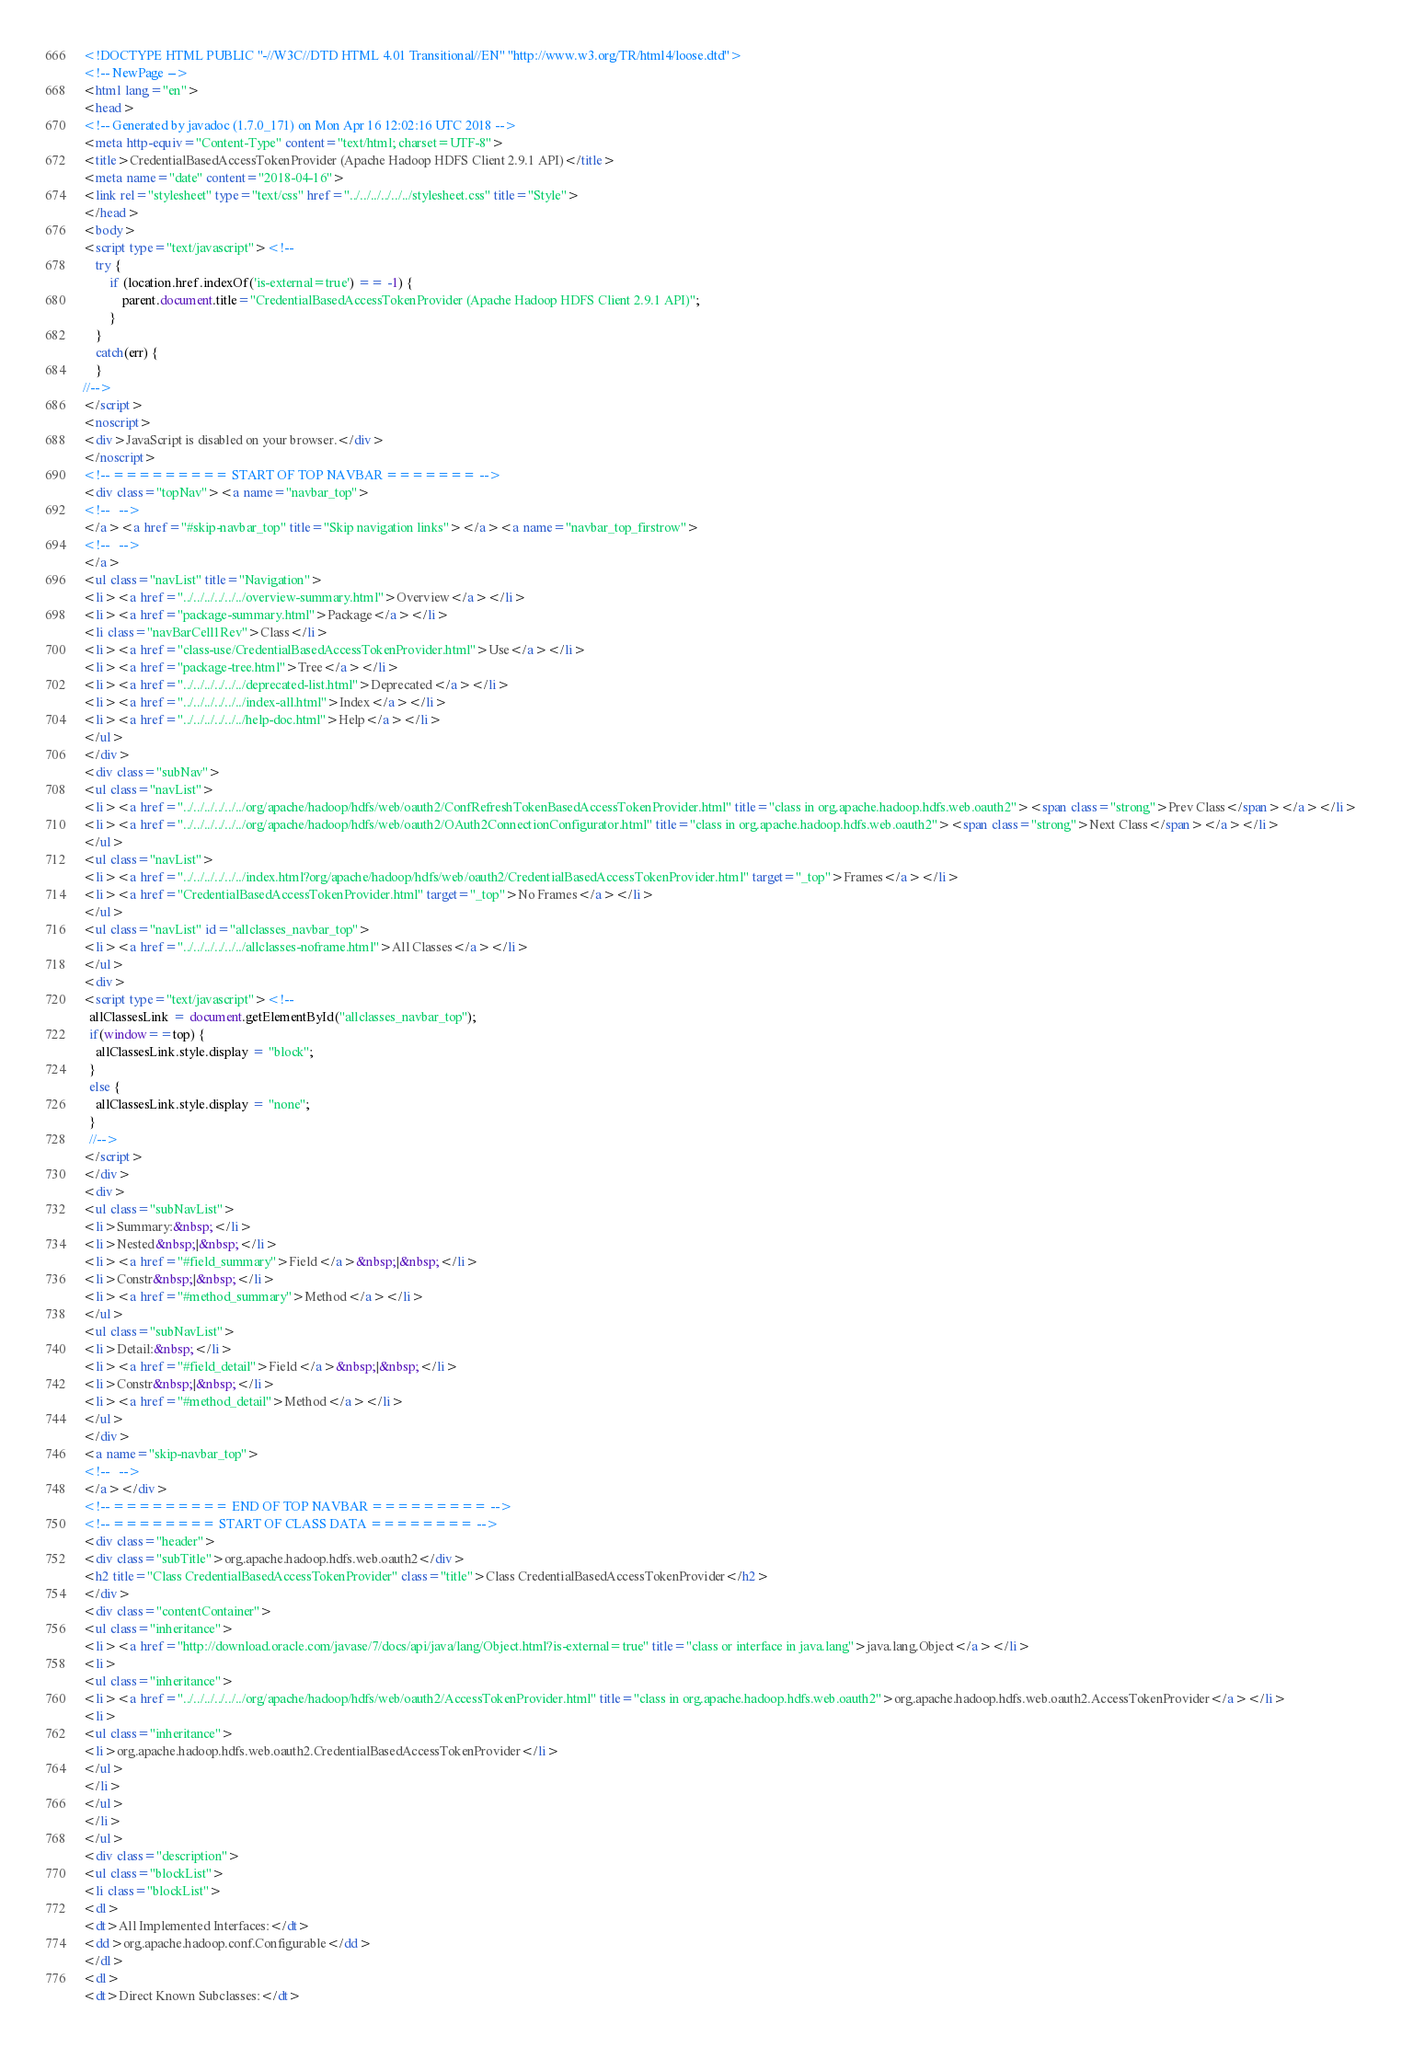Convert code to text. <code><loc_0><loc_0><loc_500><loc_500><_HTML_><!DOCTYPE HTML PUBLIC "-//W3C//DTD HTML 4.01 Transitional//EN" "http://www.w3.org/TR/html4/loose.dtd">
<!-- NewPage -->
<html lang="en">
<head>
<!-- Generated by javadoc (1.7.0_171) on Mon Apr 16 12:02:16 UTC 2018 -->
<meta http-equiv="Content-Type" content="text/html; charset=UTF-8">
<title>CredentialBasedAccessTokenProvider (Apache Hadoop HDFS Client 2.9.1 API)</title>
<meta name="date" content="2018-04-16">
<link rel="stylesheet" type="text/css" href="../../../../../../stylesheet.css" title="Style">
</head>
<body>
<script type="text/javascript"><!--
    try {
        if (location.href.indexOf('is-external=true') == -1) {
            parent.document.title="CredentialBasedAccessTokenProvider (Apache Hadoop HDFS Client 2.9.1 API)";
        }
    }
    catch(err) {
    }
//-->
</script>
<noscript>
<div>JavaScript is disabled on your browser.</div>
</noscript>
<!-- ========= START OF TOP NAVBAR ======= -->
<div class="topNav"><a name="navbar_top">
<!--   -->
</a><a href="#skip-navbar_top" title="Skip navigation links"></a><a name="navbar_top_firstrow">
<!--   -->
</a>
<ul class="navList" title="Navigation">
<li><a href="../../../../../../overview-summary.html">Overview</a></li>
<li><a href="package-summary.html">Package</a></li>
<li class="navBarCell1Rev">Class</li>
<li><a href="class-use/CredentialBasedAccessTokenProvider.html">Use</a></li>
<li><a href="package-tree.html">Tree</a></li>
<li><a href="../../../../../../deprecated-list.html">Deprecated</a></li>
<li><a href="../../../../../../index-all.html">Index</a></li>
<li><a href="../../../../../../help-doc.html">Help</a></li>
</ul>
</div>
<div class="subNav">
<ul class="navList">
<li><a href="../../../../../../org/apache/hadoop/hdfs/web/oauth2/ConfRefreshTokenBasedAccessTokenProvider.html" title="class in org.apache.hadoop.hdfs.web.oauth2"><span class="strong">Prev Class</span></a></li>
<li><a href="../../../../../../org/apache/hadoop/hdfs/web/oauth2/OAuth2ConnectionConfigurator.html" title="class in org.apache.hadoop.hdfs.web.oauth2"><span class="strong">Next Class</span></a></li>
</ul>
<ul class="navList">
<li><a href="../../../../../../index.html?org/apache/hadoop/hdfs/web/oauth2/CredentialBasedAccessTokenProvider.html" target="_top">Frames</a></li>
<li><a href="CredentialBasedAccessTokenProvider.html" target="_top">No Frames</a></li>
</ul>
<ul class="navList" id="allclasses_navbar_top">
<li><a href="../../../../../../allclasses-noframe.html">All Classes</a></li>
</ul>
<div>
<script type="text/javascript"><!--
  allClassesLink = document.getElementById("allclasses_navbar_top");
  if(window==top) {
    allClassesLink.style.display = "block";
  }
  else {
    allClassesLink.style.display = "none";
  }
  //-->
</script>
</div>
<div>
<ul class="subNavList">
<li>Summary:&nbsp;</li>
<li>Nested&nbsp;|&nbsp;</li>
<li><a href="#field_summary">Field</a>&nbsp;|&nbsp;</li>
<li>Constr&nbsp;|&nbsp;</li>
<li><a href="#method_summary">Method</a></li>
</ul>
<ul class="subNavList">
<li>Detail:&nbsp;</li>
<li><a href="#field_detail">Field</a>&nbsp;|&nbsp;</li>
<li>Constr&nbsp;|&nbsp;</li>
<li><a href="#method_detail">Method</a></li>
</ul>
</div>
<a name="skip-navbar_top">
<!--   -->
</a></div>
<!-- ========= END OF TOP NAVBAR ========= -->
<!-- ======== START OF CLASS DATA ======== -->
<div class="header">
<div class="subTitle">org.apache.hadoop.hdfs.web.oauth2</div>
<h2 title="Class CredentialBasedAccessTokenProvider" class="title">Class CredentialBasedAccessTokenProvider</h2>
</div>
<div class="contentContainer">
<ul class="inheritance">
<li><a href="http://download.oracle.com/javase/7/docs/api/java/lang/Object.html?is-external=true" title="class or interface in java.lang">java.lang.Object</a></li>
<li>
<ul class="inheritance">
<li><a href="../../../../../../org/apache/hadoop/hdfs/web/oauth2/AccessTokenProvider.html" title="class in org.apache.hadoop.hdfs.web.oauth2">org.apache.hadoop.hdfs.web.oauth2.AccessTokenProvider</a></li>
<li>
<ul class="inheritance">
<li>org.apache.hadoop.hdfs.web.oauth2.CredentialBasedAccessTokenProvider</li>
</ul>
</li>
</ul>
</li>
</ul>
<div class="description">
<ul class="blockList">
<li class="blockList">
<dl>
<dt>All Implemented Interfaces:</dt>
<dd>org.apache.hadoop.conf.Configurable</dd>
</dl>
<dl>
<dt>Direct Known Subclasses:</dt></code> 